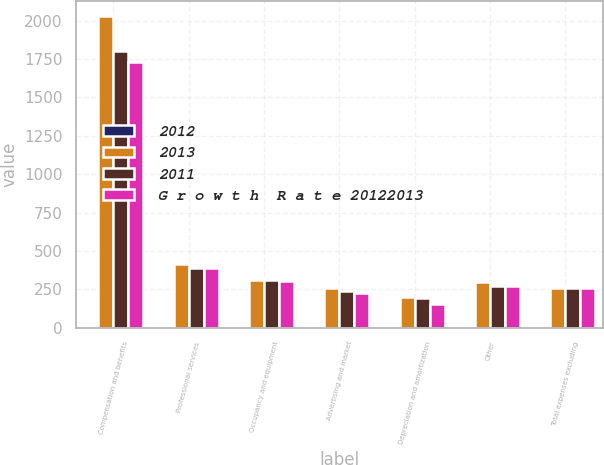<chart> <loc_0><loc_0><loc_500><loc_500><stacked_bar_chart><ecel><fcel>Compensation and benefits<fcel>Professional services<fcel>Occupancy and equipment<fcel>Advertising and market<fcel>Depreciation and amortization<fcel>Other<fcel>Total expenses excluding<nl><fcel>2012<fcel>12<fcel>7<fcel>1<fcel>7<fcel>3<fcel>9<fcel>9<nl><fcel>2013<fcel>2027<fcel>415<fcel>309<fcel>257<fcel>202<fcel>300<fcel>257<nl><fcel>2011<fcel>1803<fcel>388<fcel>311<fcel>241<fcel>196<fcel>274<fcel>257<nl><fcel>G r o w t h  R a t e 20122013<fcel>1732<fcel>387<fcel>301<fcel>228<fcel>155<fcel>269<fcel>257<nl></chart> 